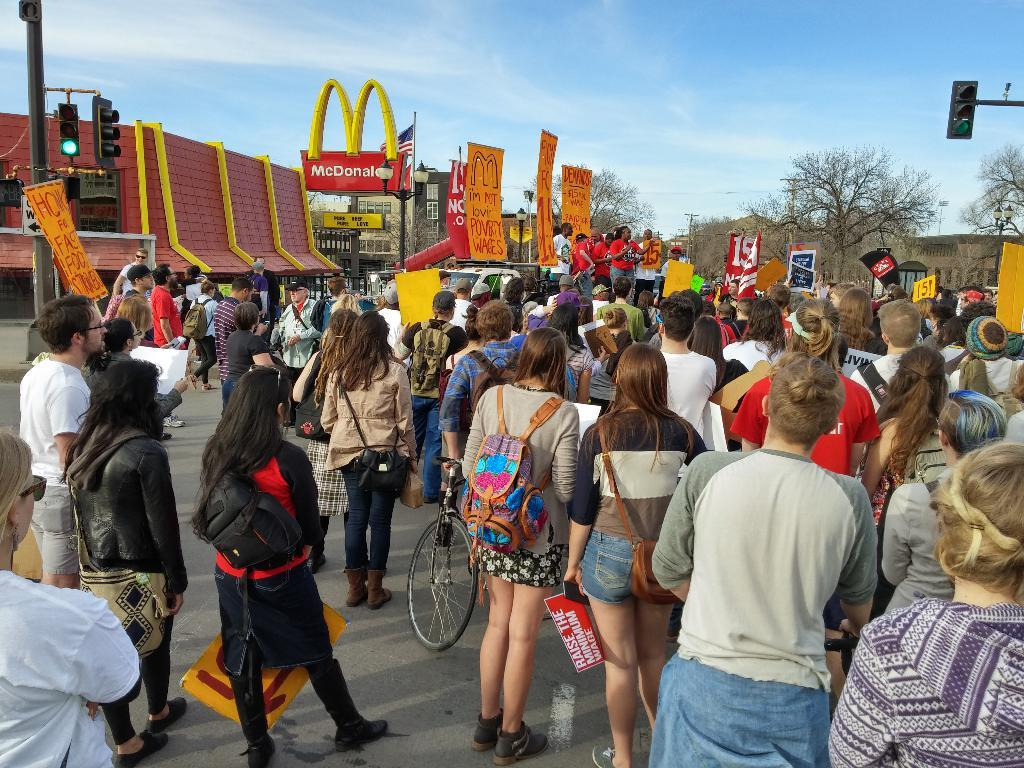What is the main subject of the image? The main subject of the image is a crowd of people. What are some people in the crowd wearing? Some people in the crowd are wearing bags. What are some people in the crowd holding? Some people in the crowd are holding placards. What can be seen in the background of the image? In the background of the image, there are banners, buildings, traffic lights with poles, trees, and the sky. How many pies are being thrown by the scarecrow in the image? There is no scarecrow or pies present in the image. 